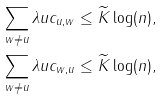<formula> <loc_0><loc_0><loc_500><loc_500>\sum _ { w \neq u } \lambda u c _ { u , w } & \leq \widetilde { K } \log ( n ) , \\ \sum _ { w \neq u } \lambda u c _ { w , u } & \leq \widetilde { K } \log ( n ) ,</formula> 